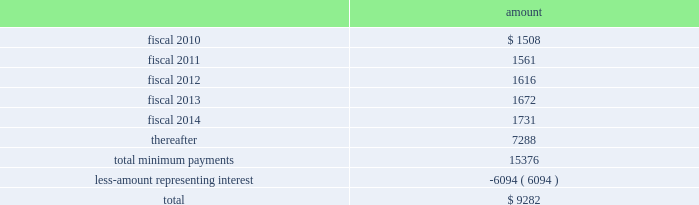Table of contents hologic , inc .
Notes to consolidated financial statements ( continued ) ( in thousands , except per share data ) location during fiscal 2009 .
The company was responsible for a significant portion of the construction costs and therefore was deemed , for accounting purposes , to be the owner of the building during the construction period , in accordance with asc 840 , leases , subsection 40-15-5 .
During the year ended september 27 , 2008 , the company recorded an additional $ 4400 in fair market value of the building , which was completed in fiscal 2008 .
This is in addition to the $ 3000 fair market value of the land and the $ 7700 fair market value related to the building constructed that cytyc had recorded as of october 22 , 2007 .
The company has recorded such fair market value within property and equipment on its consolidated balance sheets .
At september 26 , 2009 , the company has recorded $ 1508 in accrued expenses and $ 16329 in other long-term liabilities related to this obligation in the consolidated balance sheet .
The term of the lease is for a period of approximately ten years with the option to extend for two consecutive five-year terms .
The lease term commenced in may 2008 , at which time the company began transferring the company 2019s costa rican operations to this facility .
It is expected that this process will be complete by february 2009 .
At the completion of the construction period , the company reviewed the lease for potential sale-leaseback treatment in accordance with asc 840 , subsection 40 , sale-leaseback transactions ( formerly sfas no .
98 ( 201csfas 98 201d ) , accounting for leases : sale-leaseback transactions involving real estate , sales-type leases of real estate , definition of the lease term , and initial direct costs of direct financing leases 2014an amendment of financial accounting standards board ( 201cfasb 201d ) statements no .
13 , 66 , and 91 and a rescission of fasb statement no .
26 and technical bulletin no .
79-11 ) .
Based on its analysis , the company determined that the lease did not qualify for sale-leaseback treatment .
Therefore , the building , leasehold improvements and associated liabilities will remain on the company 2019s financial statements throughout the lease term , and the building and leasehold improvements will be depreciated on a straight line basis over their estimated useful lives of 35 years .
Future minimum lease payments , including principal and interest , under this lease were as follows at september 26 , 2009: .
In addition , as a result of the merger with cytyc , the company assumed the obligation to a non-cancelable lease agreement for a building with approximately 146000 square feet located in marlborough , massachusetts , to be principally used as an additional manufacturing facility .
In 2011 , the company will have an option to lease an additional 30000 square feet .
As part of the lease agreement , the lessor agreed to allow the company to make significant renovations to the facility to prepare the facility for the company 2019s manufacturing needs .
The company was responsible for a significant amount of the construction costs and therefore was deemed , for accounting purposes , to be the owner of the building during the construction period in accordance with asc 840-40-15-5 .
The $ 13200 fair market value of the facility is included within property and equipment , net on the consolidated balance sheet .
At september 26 , 2009 , the company has recorded $ 982 in accrued expenses and source : hologic inc , 10-k , november 24 , 2009 powered by morningstar ae document research 2120 the information contained herein may not be copied , adapted or distributed and is not warranted to be accurate , complete or timely .
The user assumes all risks for any damages or losses arising from any use of this information , except to the extent such damages or losses cannot be limited or excluded by applicable law .
Past financial performance is no guarantee of future results. .
What portion of the total minimum payment is related to interest? 
Computations: (6094 / 15376)
Answer: 0.39633. 